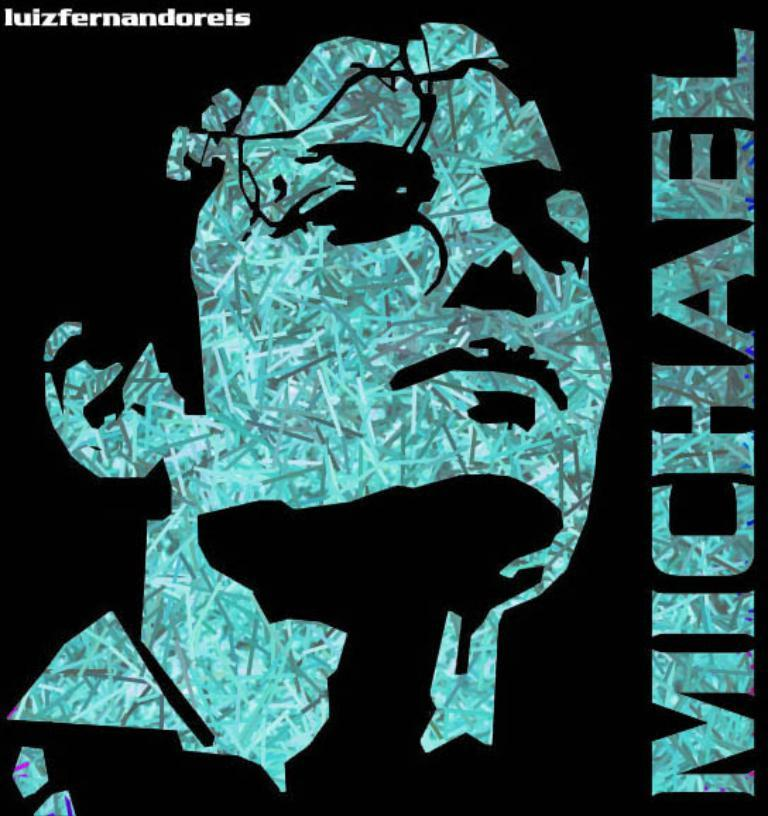What is the main subject of the image? There is a depiction of a person in the image. Can you describe any additional elements related to the person in the image? There is text associated with the person in the image. What type of leather is being used to make the bun in the image? There is no bun or leather present in the image; it features a depiction of a person with associated text. 